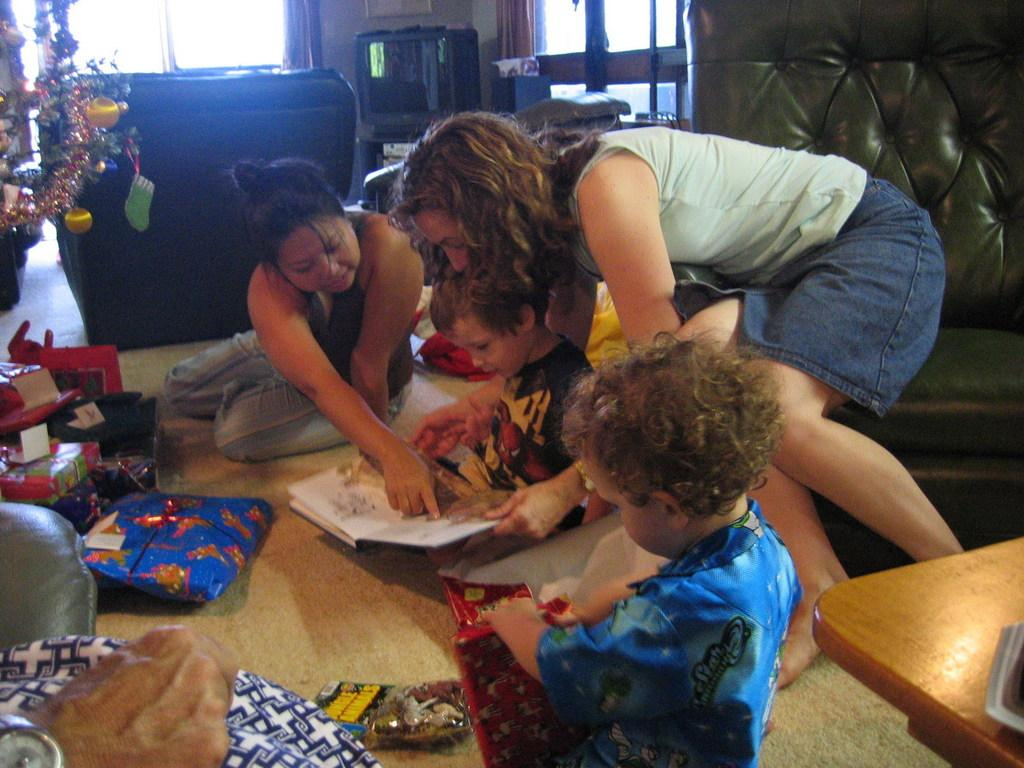What are the people in the image doing? There is a group of people sitting on the floor. What furniture can be seen in the background? There is a couch and a table in the background. What electronic device is present in the background? There is a television in the background. What seasonal decoration is visible in the background? There is a Christmas tree in the background. What items are associated with the Christmas tree? There are gifts in the background. What type of cap is the person wearing in the image? There is no person wearing a cap in the image. 